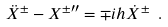Convert formula to latex. <formula><loc_0><loc_0><loc_500><loc_500>\ddot { X } ^ { \pm } - X ^ { \pm \prime \prime } = \mp i h \dot { X } ^ { \pm } \ .</formula> 